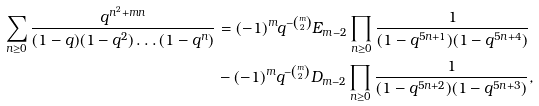Convert formula to latex. <formula><loc_0><loc_0><loc_500><loc_500>\sum _ { n \geq 0 } \frac { q ^ { n ^ { 2 } + m n } } { ( 1 - q ) ( 1 - q ^ { 2 } ) \dots ( 1 - q ^ { n } ) } & = ( - 1 ) ^ { m } q ^ { - \binom { m } { 2 } } E _ { m - 2 } \prod _ { n \geq 0 } \frac { 1 } { ( 1 - q ^ { 5 n + 1 } ) ( 1 - q ^ { 5 n + 4 } ) } \\ & - ( - 1 ) ^ { m } q ^ { - \binom { m } { 2 } } D _ { m - 2 } \prod _ { n \geq 0 } \frac { 1 } { ( 1 - q ^ { 5 n + 2 } ) ( 1 - q ^ { 5 n + 3 } ) } ,</formula> 